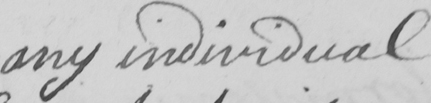Can you read and transcribe this handwriting? any individual 